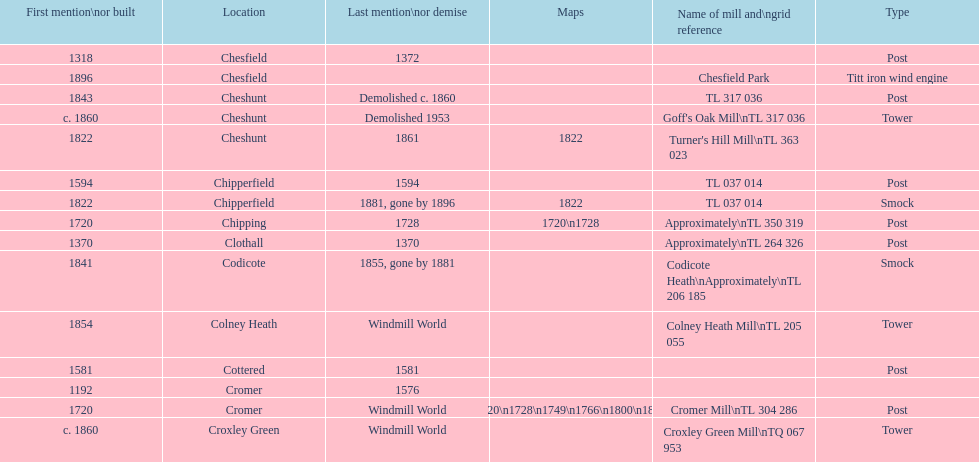What location has the most maps? Cromer. Help me parse the entirety of this table. {'header': ['First mention\\nor built', 'Location', 'Last mention\\nor demise', 'Maps', 'Name of mill and\\ngrid reference', 'Type'], 'rows': [['1318', 'Chesfield', '1372', '', '', 'Post'], ['1896', 'Chesfield', '', '', 'Chesfield Park', 'Titt iron wind engine'], ['1843', 'Cheshunt', 'Demolished c. 1860', '', 'TL 317 036', 'Post'], ['c. 1860', 'Cheshunt', 'Demolished 1953', '', "Goff's Oak Mill\\nTL 317 036", 'Tower'], ['1822', 'Cheshunt', '1861', '1822', "Turner's Hill Mill\\nTL 363 023", ''], ['1594', 'Chipperfield', '1594', '', 'TL 037 014', 'Post'], ['1822', 'Chipperfield', '1881, gone by 1896', '1822', 'TL 037 014', 'Smock'], ['1720', 'Chipping', '1728', '1720\\n1728', 'Approximately\\nTL 350 319', 'Post'], ['1370', 'Clothall', '1370', '', 'Approximately\\nTL 264 326', 'Post'], ['1841', 'Codicote', '1855, gone by 1881', '', 'Codicote Heath\\nApproximately\\nTL 206 185', 'Smock'], ['1854', 'Colney Heath', 'Windmill World', '', 'Colney Heath Mill\\nTL 205 055', 'Tower'], ['1581', 'Cottered', '1581', '', '', 'Post'], ['1192', 'Cromer', '1576', '', '', ''], ['1720', 'Cromer', 'Windmill World', '1720\\n1728\\n1749\\n1766\\n1800\\n1822', 'Cromer Mill\\nTL 304 286', 'Post'], ['c. 1860', 'Croxley Green', 'Windmill World', '', 'Croxley Green Mill\\nTQ 067 953', 'Tower']]} 